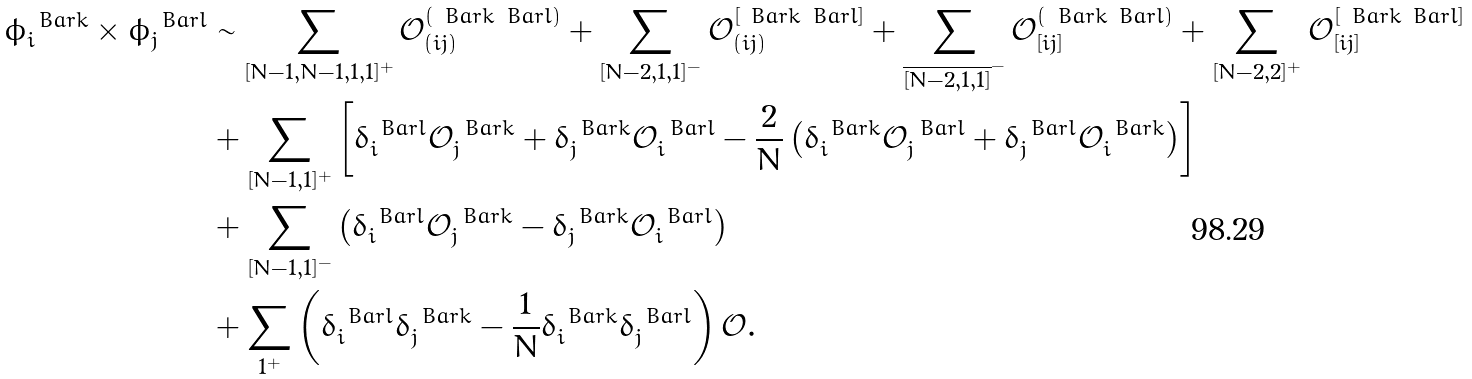<formula> <loc_0><loc_0><loc_500><loc_500>\phi _ { i } ^ { \ B a r { k } } \times \phi _ { j } ^ { \ B a r { l } } & \sim \sum _ { [ N - 1 , N - 1 , 1 , 1 ] ^ { + } } \mathcal { O } _ { ( i j ) } ^ { ( \ B a r { k } \ B a r { l } ) } + \sum _ { [ N - 2 , 1 , 1 ] ^ { - } } \mathcal { O } _ { ( i j ) } ^ { [ \ B a r { k } \ B a r { l } ] } + \sum _ { \overline { [ N - 2 , 1 , 1 ] } ^ { - } } \mathcal { O } _ { [ i j ] } ^ { ( \ B a r { k } \ B a r { l } ) } + \sum _ { [ N - 2 , 2 ] ^ { + } } \mathcal { O } _ { [ i j ] } ^ { [ \ B a r { k } \ B a r { l } ] } \\ & + \sum _ { [ N - 1 , 1 ] ^ { + } } \left [ \delta _ { i } ^ { \ B a r { l } } \mathcal { O } _ { j } ^ { \ B a r { k } } + \delta _ { j } ^ { \ B a r { k } } \mathcal { O } _ { i } ^ { \ B a r { l } } - \frac { 2 } { N } \left ( \delta _ { i } ^ { \ B a r { k } } \mathcal { O } _ { j } ^ { \ B a r { l } } + \delta _ { j } ^ { \ B a r { l } } \mathcal { O } _ { i } ^ { \ B a r { k } } \right ) \right ] \\ & + \sum _ { [ N - 1 , 1 ] ^ { - } } \left ( \delta _ { i } ^ { \ B a r { l } } \mathcal { O } _ { j } ^ { \ B a r { k } } - \delta _ { j } ^ { \ B a r { k } } \mathcal { O } _ { i } ^ { \ B a r { l } } \right ) \\ & + \sum _ { 1 ^ { + } } \left ( \delta _ { i } ^ { \ B a r { l } } \delta _ { j } ^ { \ B a r { k } } - \frac { 1 } { N } \delta _ { i } ^ { \ B a r { k } } \delta _ { j } ^ { \ B a r { l } } \right ) \mathcal { O } .</formula> 